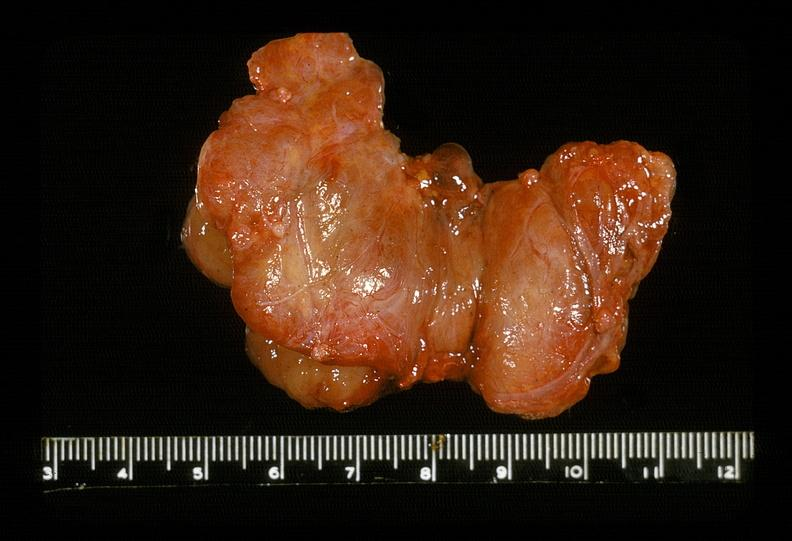does this image show thyroid, hashimotos?
Answer the question using a single word or phrase. Yes 